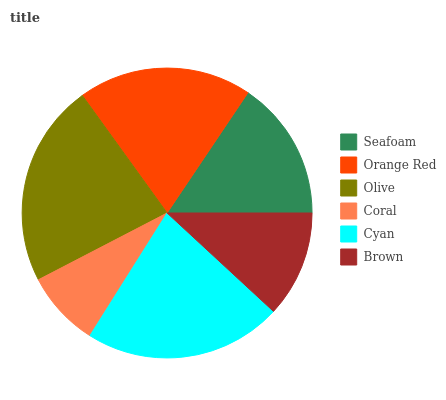Is Coral the minimum?
Answer yes or no. Yes. Is Olive the maximum?
Answer yes or no. Yes. Is Orange Red the minimum?
Answer yes or no. No. Is Orange Red the maximum?
Answer yes or no. No. Is Orange Red greater than Seafoam?
Answer yes or no. Yes. Is Seafoam less than Orange Red?
Answer yes or no. Yes. Is Seafoam greater than Orange Red?
Answer yes or no. No. Is Orange Red less than Seafoam?
Answer yes or no. No. Is Orange Red the high median?
Answer yes or no. Yes. Is Seafoam the low median?
Answer yes or no. Yes. Is Coral the high median?
Answer yes or no. No. Is Olive the low median?
Answer yes or no. No. 